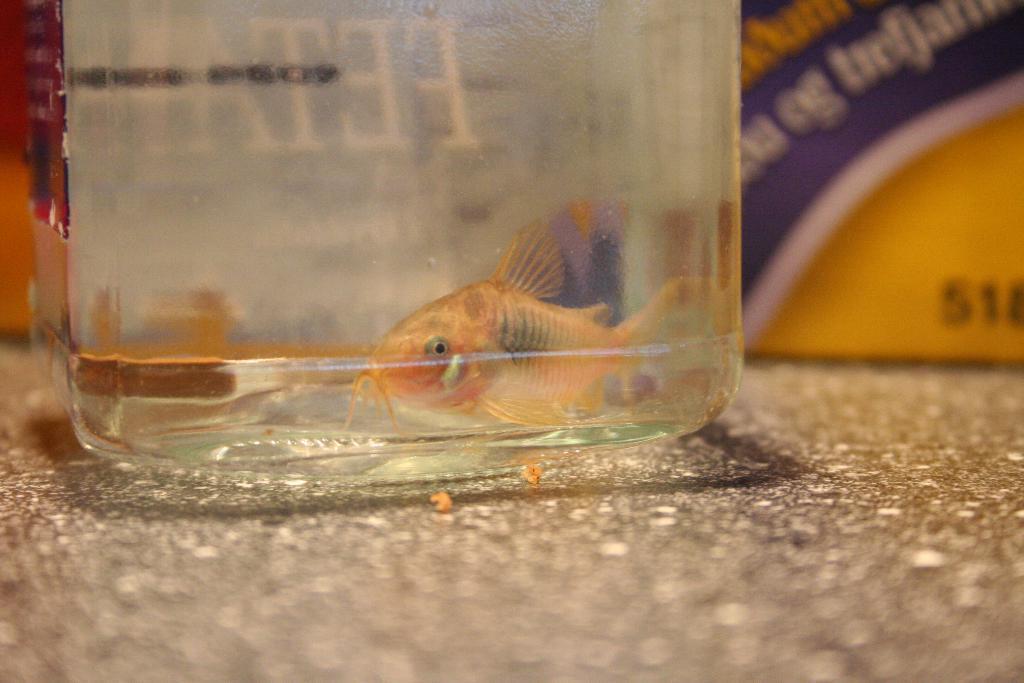Please provide a concise description of this image. In this image I see a container and I see a fish in it which is gold in color and I see the surface. In the background I see something is written over here. 